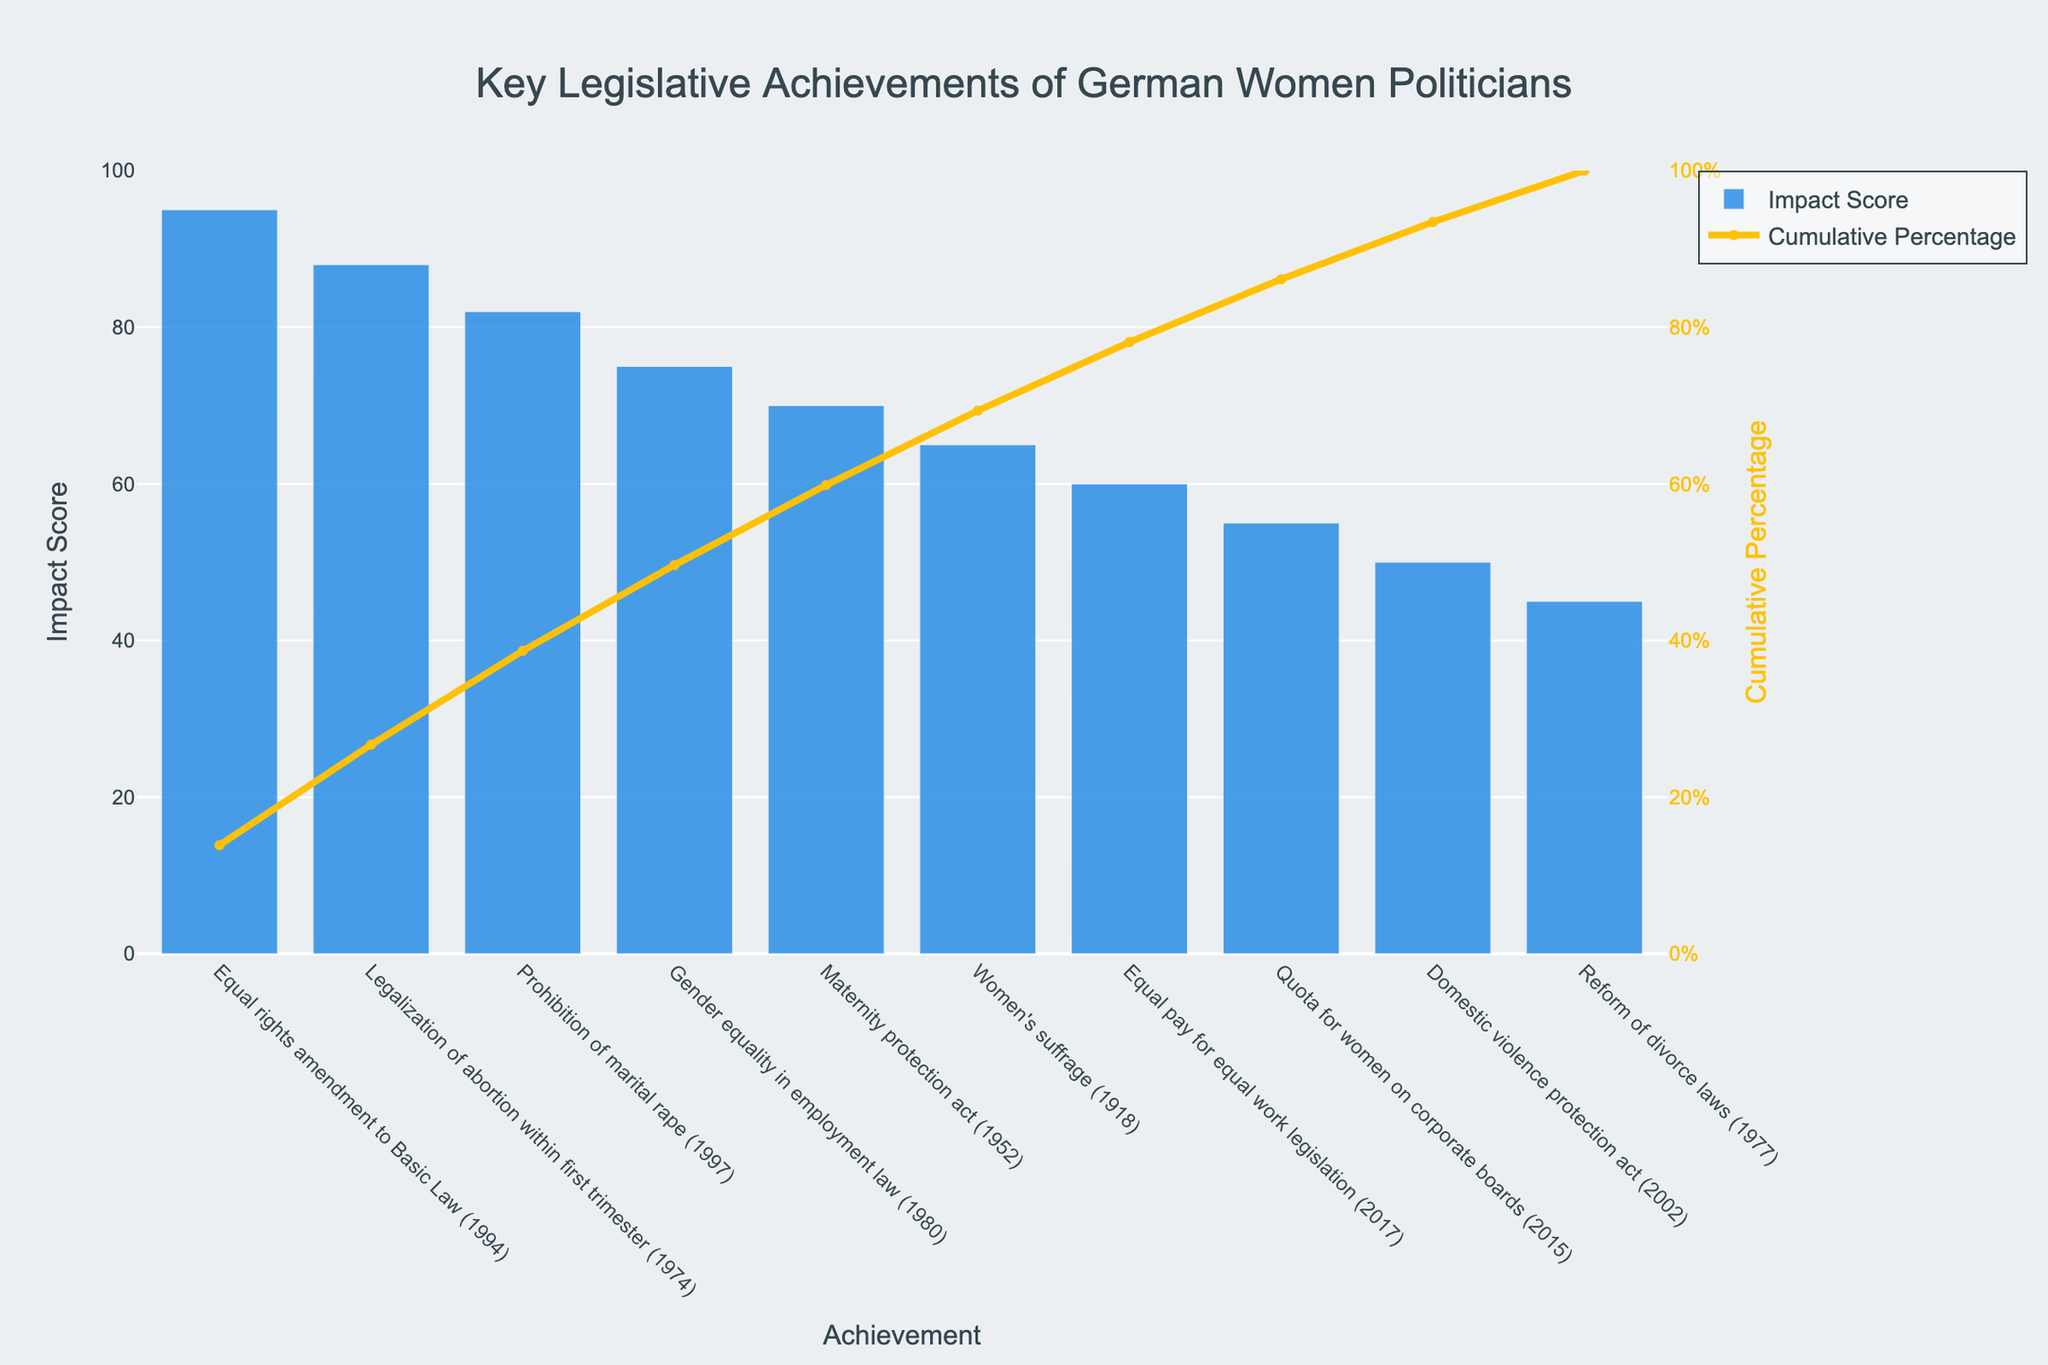What is the title of the Pareto chart? The title of the chart is located at the top and is visually distinct due to its larger font size and centered alignment.
Answer: Key Legislative Achievements of German Women Politicians What achievement has the highest impact score? To determine this, look for the tallest bar in the bar plot, which indicates the highest impact score. The tallest bar corresponds to the 'Equal rights amendment to Basic Law (1994)'.
Answer: Equal rights amendment to Basic Law (1994) Which legislative achievement is associated with the lowest impact score? Examine the bar that is the shortest among all the bars in the chart, indicating the smallest impact score. The shortest bar represents the 'Reform of divorce laws (1977)'.
Answer: Reform of divorce laws (1977) What is the cumulative percentage after the first three achievements? To find this, look at the cumulative percentage line and check the value above the third bar from the left. These bars are 'Equal rights amendment to Basic Law (1994)', 'Legalization of abortion within first trimester (1974)', and 'Prohibition of marital rape (1997)'. The cumulative percentage for these three achievements is approximately 76.79%.
Answer: 76.79% How many achievements have an impact score greater than 70? Count the number of bars that extend above the 70 mark on the impact score axis. These bars represent 'Equal rights amendment to Basic Law (1994)', 'Legalization of abortion within first trimester (1974)', and 'Prohibition of marital rape (1997)'.
Answer: 3 Which legislative achievement marked in 2017 and what is its impact score? Identify the achievement corresponding to 2017 by looking for the year in the labels under the bars, and observe its height to find the impact score. The achievement is 'Equal pay for equal work legislation' with an impact score of 60.
Answer: Equal pay for equal work legislation (2017), 60 Which achievement has a lower impact score, 'Domestic violence protection act (2002)' or 'Quota for women on corporate boards (2015)'? By comparing the heights of the two bars labeled 'Domestic violence protection act (2002)' and 'Quota for women on corporate boards (2015)', you can observe that the 'Domestic violence protection act (2002)' has a lower impact score of 50 compared to 55 for the other.
Answer: Domestic violence protection act (2002) What is the average impact score of all legislative achievements shown? Add all the impact scores: 95 + 88 + 82 + 75 + 70 + 65 + 60 + 55 + 50 + 45 = 685, then divide by the number of achievements (10). The average impact score is 68.5.
Answer: 68.5 